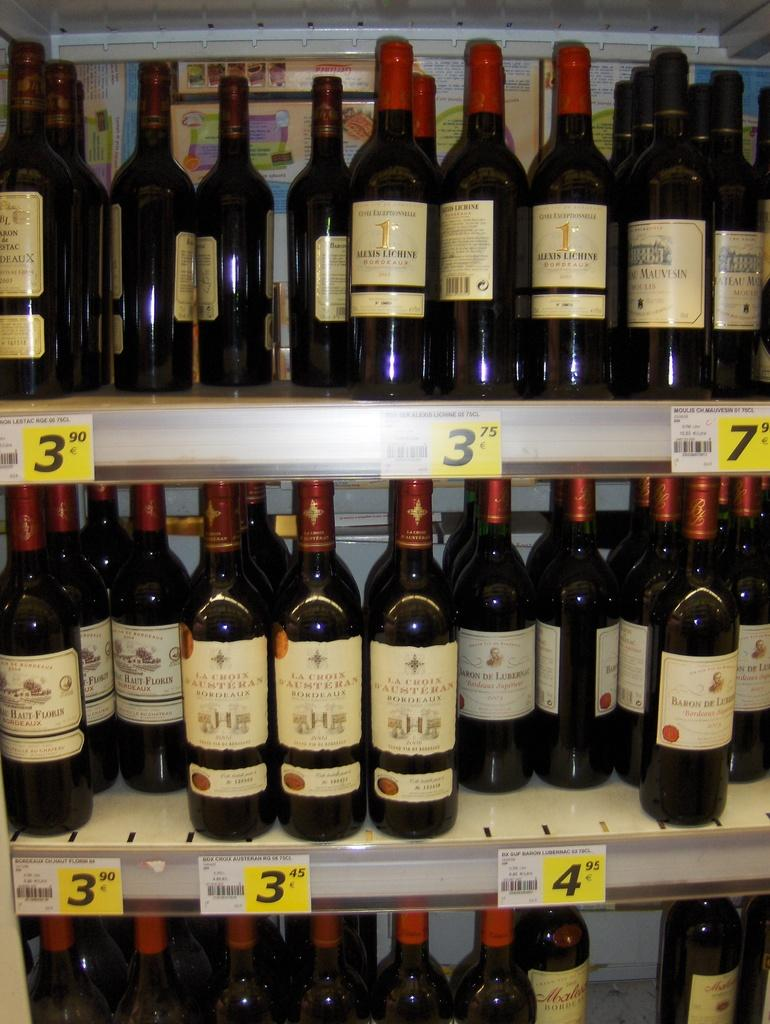What objects are visible in the image? There are bottles in the image. Where are the bottles located? The bottles are in a cupboard. What type of wing is visible in the image? There is no wing present in the image; it only features bottles in a cupboard. 